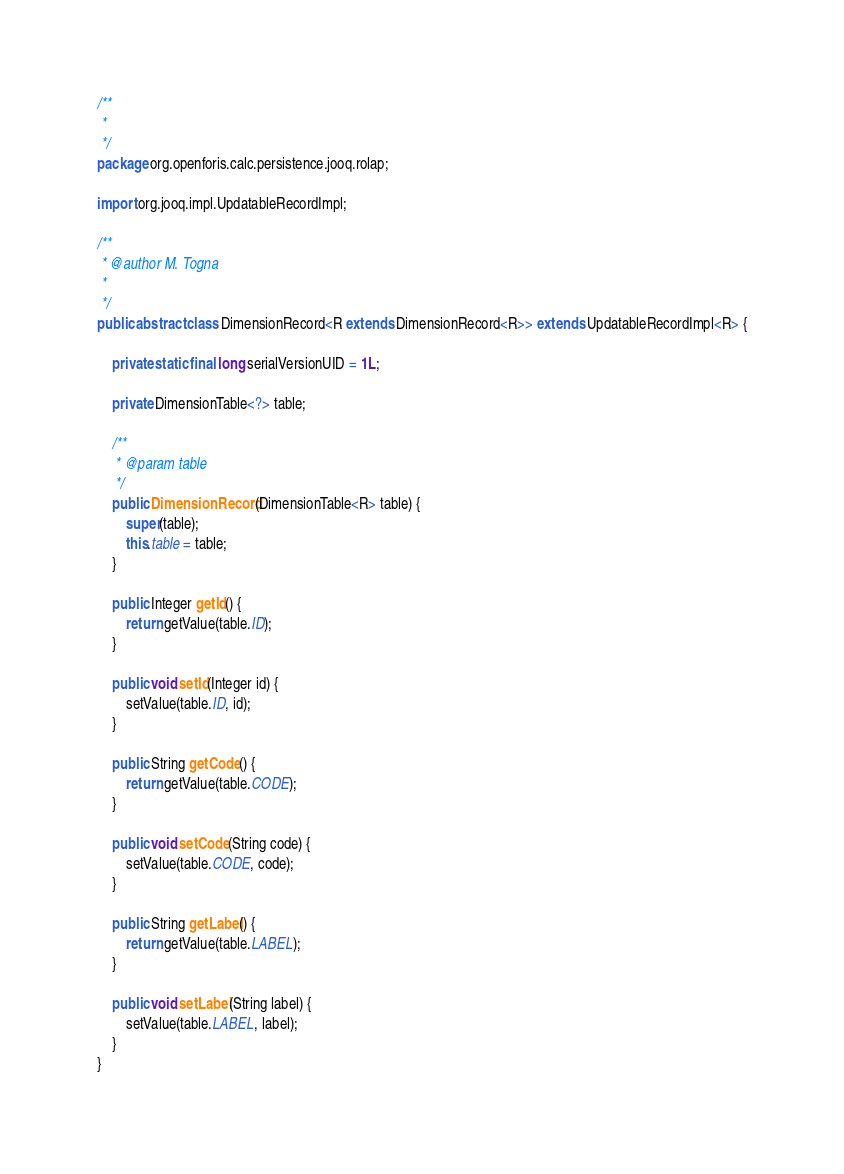<code> <loc_0><loc_0><loc_500><loc_500><_Java_>/**
 * 
 */
package org.openforis.calc.persistence.jooq.rolap;

import org.jooq.impl.UpdatableRecordImpl;

/**
 * @author M. Togna
 * 
 */
public abstract class DimensionRecord<R extends DimensionRecord<R>> extends UpdatableRecordImpl<R> {

	private static final long serialVersionUID = 1L;

	private DimensionTable<?> table;

	/**
	 * @param table
	 */
	public DimensionRecord(DimensionTable<R> table) {
		super(table);
		this.table = table;
	}

	public Integer getId() {
		return getValue(table.ID);
	}

	public void setId(Integer id) {
		setValue(table.ID, id);
	}

	public String getCode() {
		return getValue(table.CODE);
	}

	public void setCode(String code) {
		setValue(table.CODE, code);
	}

	public String getLabel() {
		return getValue(table.LABEL);
	}

	public void setLabel(String label) {
		setValue(table.LABEL, label);
	}
}
</code> 